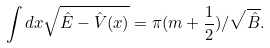Convert formula to latex. <formula><loc_0><loc_0><loc_500><loc_500>\int d x \sqrt { \hat { E } - \hat { V } ( x ) } = \pi ( m + \frac { 1 } { 2 } ) / \sqrt { \hat { B } } .</formula> 